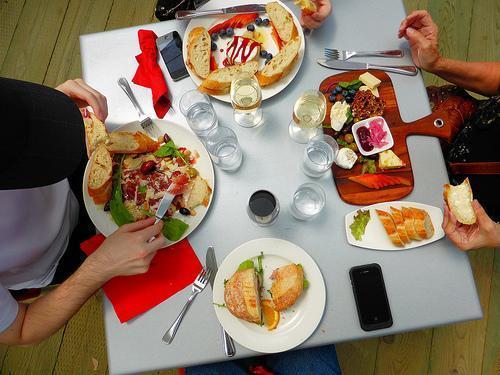How many plates are on the table?
Give a very brief answer. 4. How many of the glasses are filled with white wine?
Give a very brief answer. 2. 